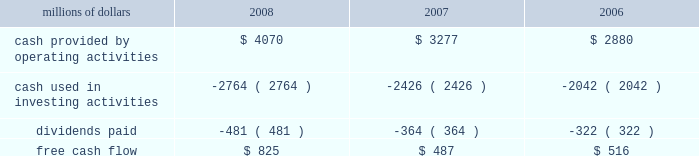Levels during 2008 , an indication that efforts to improve network operations translated into better customer service .
2022 fuel prices 2013 crude oil prices increased at a steady rate through the first seven months of 2008 , closing at a record high of $ 145.29 a barrel in early july .
As the economy worsened during the third and fourth quarters , fuel prices dropped dramatically , hitting $ 33.87 per barrel in december , a near five-year low .
Despite these price declines toward the end of the year , our 2008 average fuel price increased by 39% ( 39 % ) and added $ 1.1 billion of operating expenses compared to 2007 .
Our fuel surcharge programs helped offset the impact of higher fuel prices .
In addition , we reduced our consumption rate by 4% ( 4 % ) , saving approximately 58 million gallons of fuel during the year .
The use of newer , more fuel efficient locomotives ; our fuel conservation programs ; improved network operations ; and a shift in commodity mix , primarily due to growth in bulk shipments , contributed to the improvement .
2022 free cash flow 2013 cash generated by operating activities totaled a record $ 4.1 billion , yielding free cash flow of $ 825 million in 2008 .
Free cash flow is defined as cash provided by operating activities , less cash used in investing activities and dividends paid .
Free cash flow is not considered a financial measure under accounting principles generally accepted in the united states ( gaap ) by sec regulation g and item 10 of sec regulation s-k .
We believe free cash flow is important in evaluating our financial performance and measures our ability to generate cash without additional external financings .
Free cash flow should be considered in addition to , rather than as a substitute for , cash provided by operating activities .
The table reconciles cash provided by operating activities ( gaap measure ) to free cash flow ( non-gaap measure ) : millions of dollars 2008 2007 2006 .
2009 outlook 2022 safety 2013 operating a safe railroad benefits our employees , our customers , our shareholders , and the public .
We will continue using a multi-faceted approach to safety , utilizing technology , risk assessment , quality control , and training and engaging our employees .
We plan to continue implementation of total safety culture ( tsc ) throughout our operations .
Tsc , an employee-focused initiative that has helped improve safety , is a process designed to establish , maintain , and promote safety among co-workers .
With respect to public safety , we will continue our efforts to maintain , upgrade , and close crossings , install video cameras on locomotives , and educate the public about crossing safety through various railroad and industry programs , along with other activities .
2022 transportation plan 2013 in 2009 , we will continue to evaluate traffic flows and network logistic patterns to identify additional opportunities to simplify operations and improve network efficiency and asset utilization .
We plan to maintain adequate manpower and locomotives , and improve productivity using industrial engineering techniques .
2022 fuel prices 2013 on average , we expect fuel prices to decrease substantially from the average price we paid in 2008 .
However , due to economic uncertainty , other global pressures , and weather incidents , fuel prices again could be volatile during the year .
To reduce the impact of fuel price on earnings , we .
What was the percent of the cash provided by operating activities? 
Computations: ((3277 - 2880) / 2880)
Answer: 0.13785. 